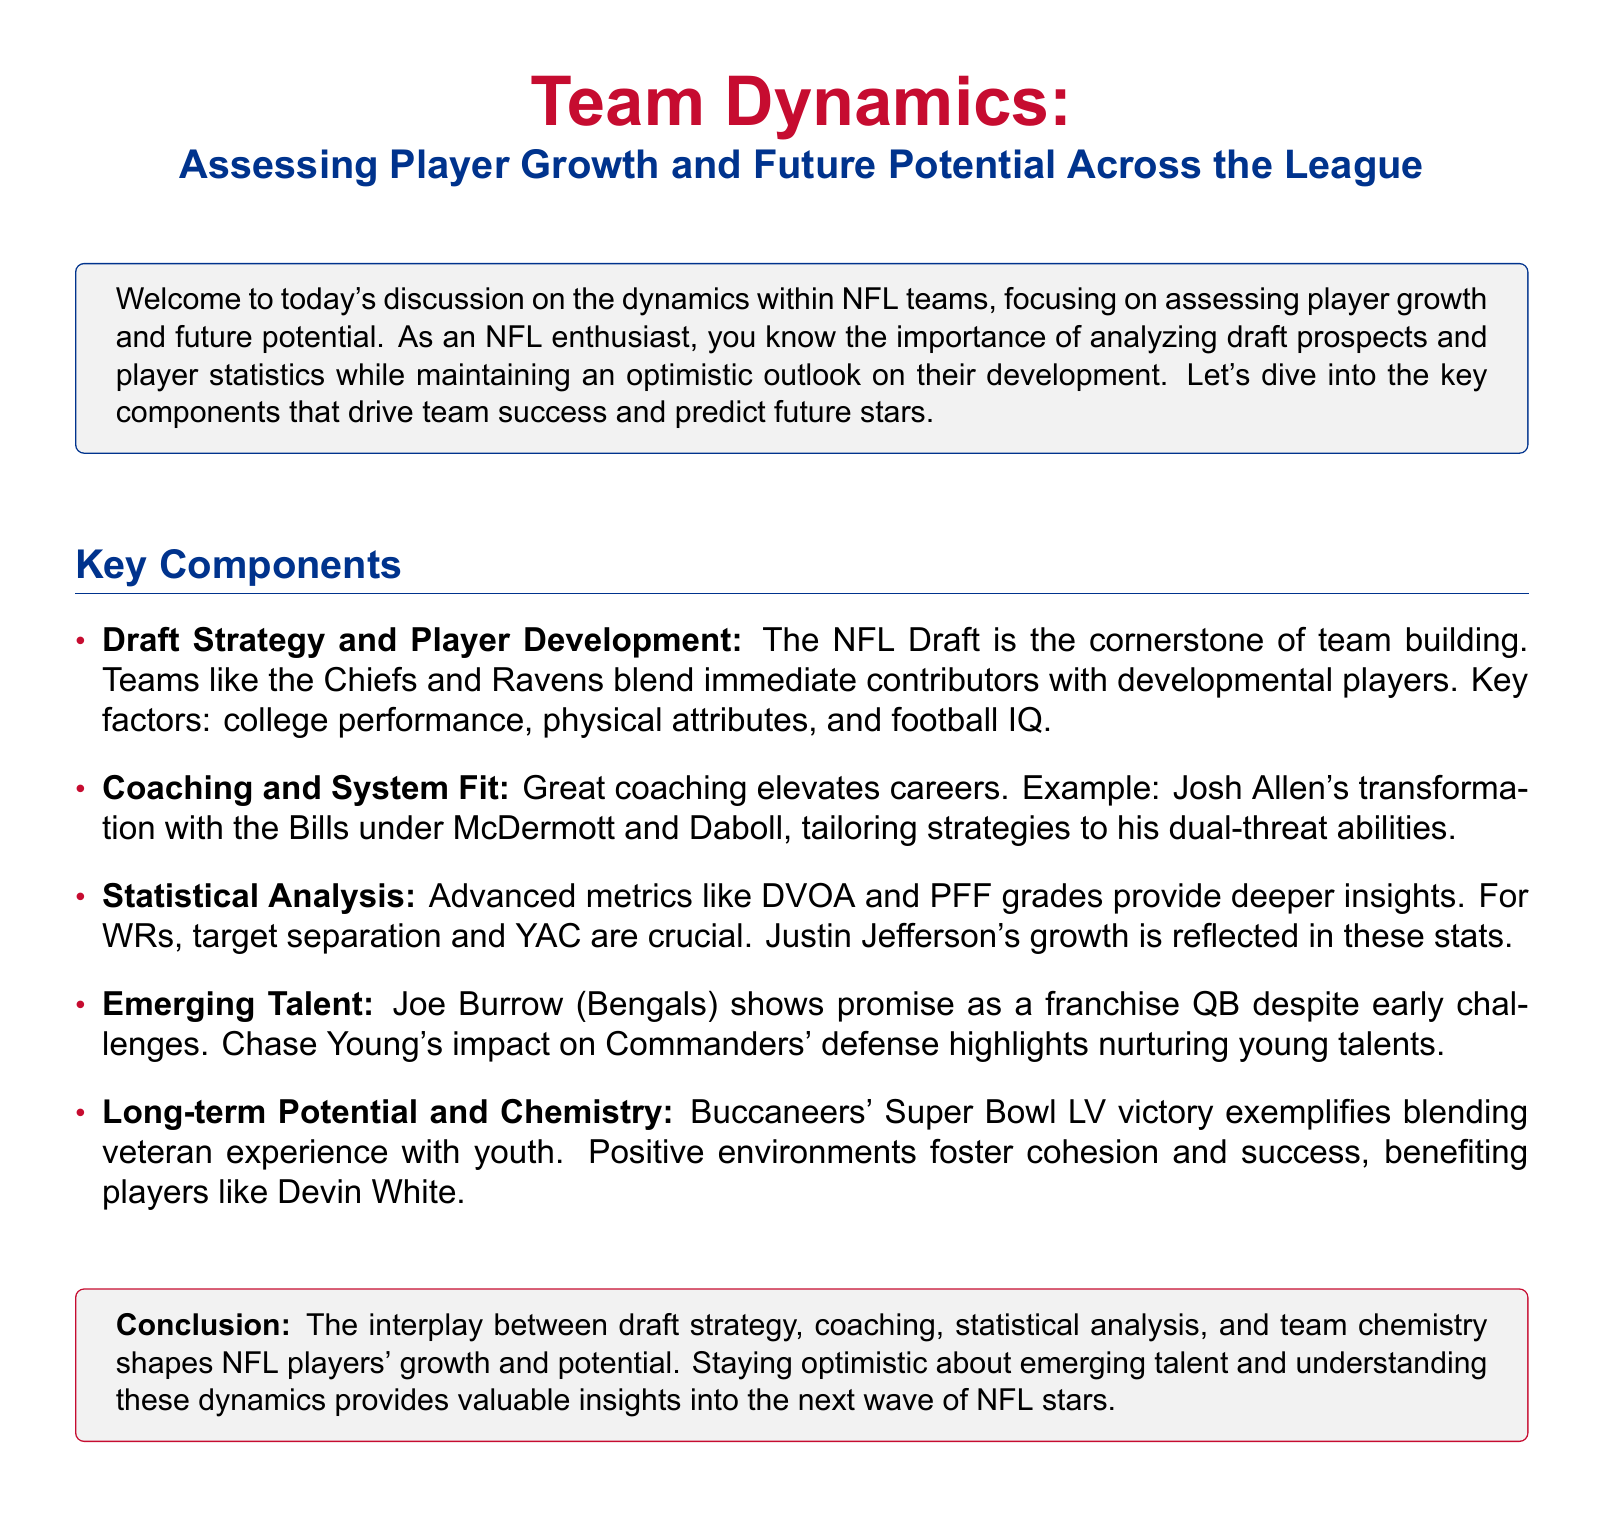What is the cornerstone of team building? The document states that the NFL Draft is the cornerstone of team building.
Answer: NFL Draft Which teams are mentioned for blending contributors? The Chiefs and Ravens are mentioned as examples of teams that blend immediate contributors with developmental players.
Answer: Chiefs and Ravens Who transformed Josh Allen's career? The document indicates that McDermott and Daboll played a significant role in transforming Josh Allen's career.
Answer: McDermott and Daboll What metrics provide deeper insights into player performance? Advanced metrics like DVOA and PFF grades are highlighted as providing deeper insights into player performance.
Answer: DVOA and PFF grades Which quarterback shows promise despite early challenges? Joe Burrow is mentioned as a quarterback showing promise despite his early challenges.
Answer: Joe Burrow What does the Buccaneers' Super Bowl LV victory exemplify? The Buccaneers' Super Bowl LV victory exemplifies blending veteran experience with youth.
Answer: Blending veteran experience with youth Which player is noted for their impact on the Commanders' defense? Chase Young is noted for his impact on the Commanders' defense.
Answer: Chase Young What is crucial for wide receivers according to the document? Target separation and YAC (yards after catch) are crucial for wide receivers.
Answer: Target separation and YAC What does the document encourage regarding emerging talent? The document encourages maintaining an optimistic outlook about emerging talent.
Answer: Optimistic outlook 